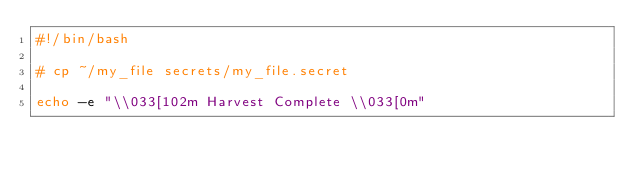<code> <loc_0><loc_0><loc_500><loc_500><_Bash_>#!/bin/bash

# cp ~/my_file secrets/my_file.secret

echo -e "\\033[102m Harvest Complete \\033[0m"
</code> 